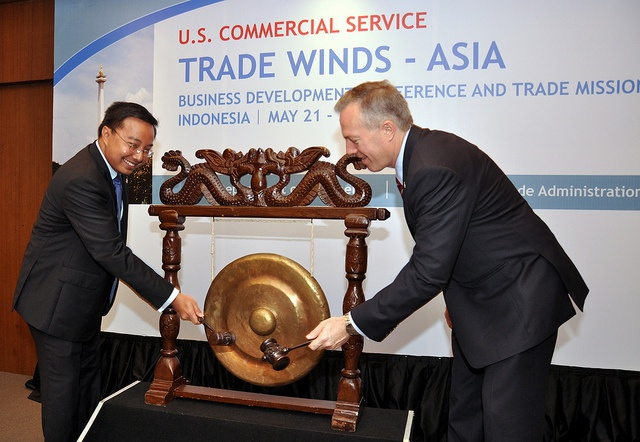Describe the objects in this image and their specific colors. I can see people in black, tan, gray, and darkgray tones, people in black, maroon, tan, and brown tones, tie in black, gray, blue, and navy tones, and tie in black, maroon, and gray tones in this image. 